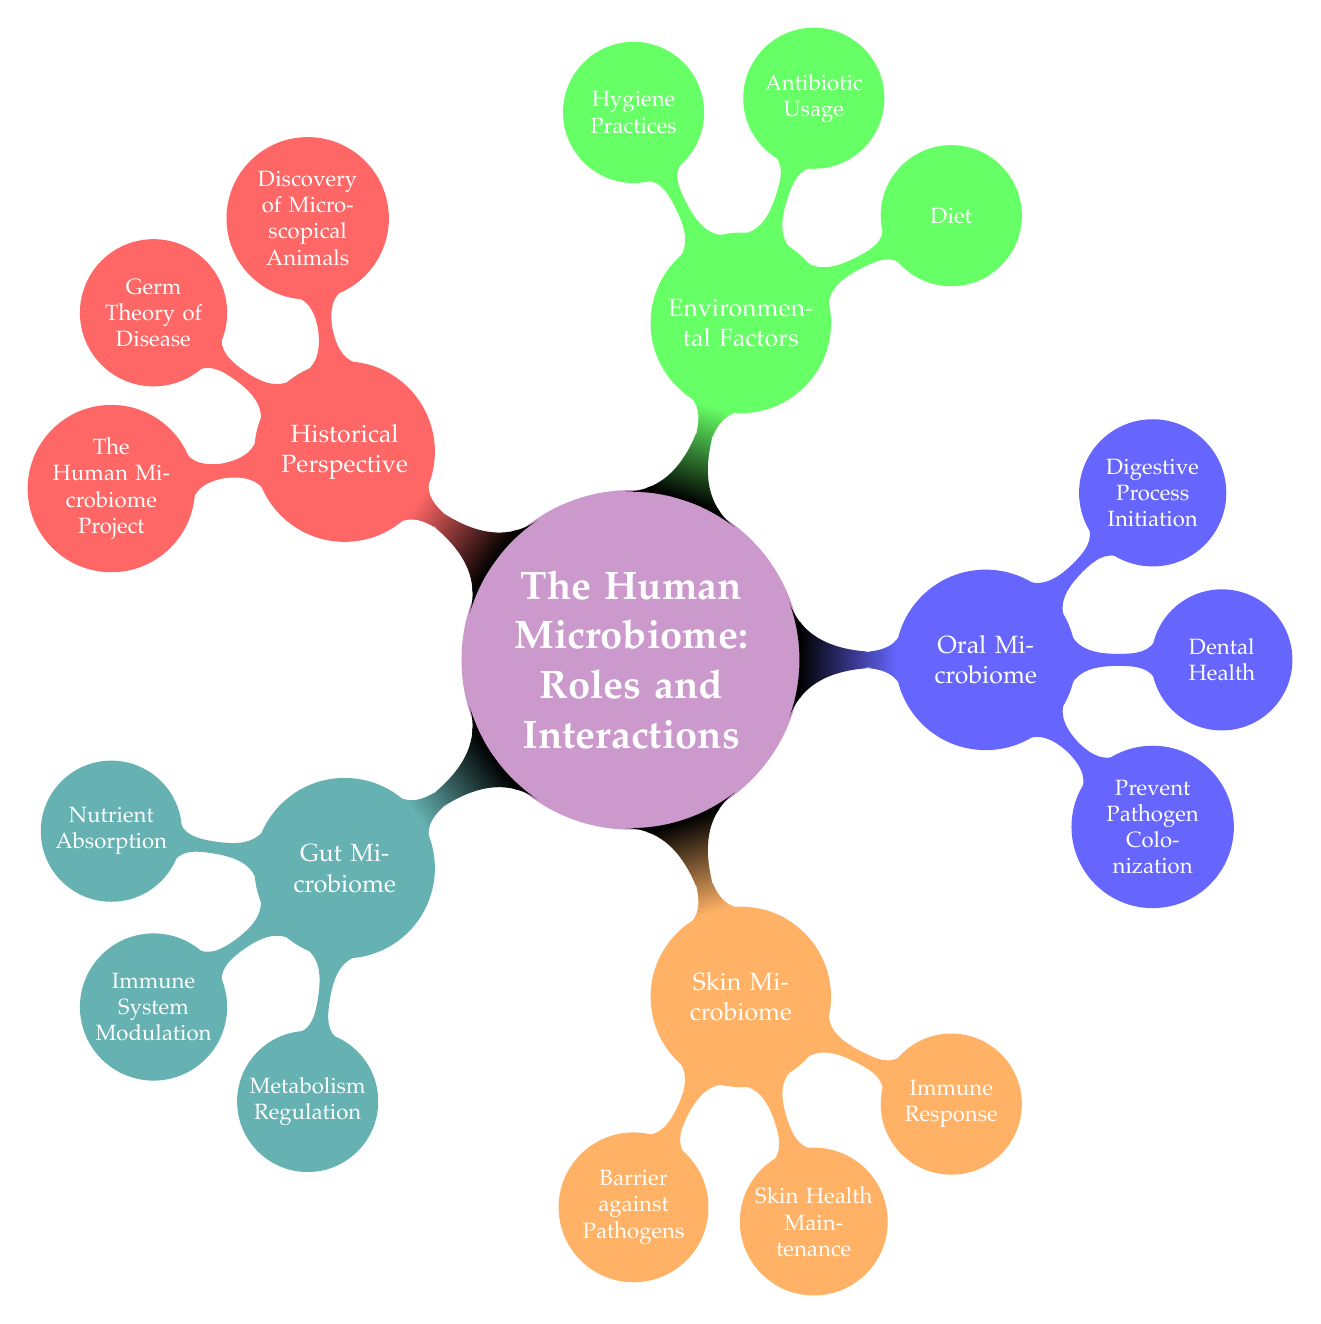What is the central concept of the diagram? The central concept is directly stated as "The Human Microbiome: Roles and Interactions" at the root level of the mind map.
Answer: The Human Microbiome: Roles and Interactions How many main types of microbiomes are presented in the diagram? The diagram presents five main types of microbiomes, which can be counted as Gut Microbiome, Skin Microbiome, Oral Microbiome, Environmental Factors, and Historical Perspective.
Answer: Five What is one of the key roles of the Gut Microbiome? The roles of the Gut Microbiome include nutrient absorption, immune system modulation, and metabolism regulation. Any of these roles can be considered as valid answers.
Answer: Nutrient Absorption Which microbiome is responsible for barrier against pathogens? The Skin Microbiome is specifically noted to have the role of providing a barrier against pathogens, as listed under its roles.
Answer: Skin Microbiome What external factors influence the human microbiome? The diagram specifies three external factors: diet, antibiotic usage, and hygiene practices that affect the human microbiome. The answer can list any of these factors.
Answer: Diet Which historical milestone is related to the discovery of microscopical animals? The milestone related to the discovery of microscopical animals is attributed to Antonie van Leeuwenhoek, indicated under the Historical Perspective node.
Answer: Discovery of Microscopical Animals How does diet impact the human microbiome according to the diagram? Diet influences the microbiome by affecting its diversity as stated under the Environmental Factors node, which discusses the impact of various external elements.
Answer: Microbiome Diversity Name a key organism found in the Oral Microbiome. The Oral Microbiome includes key organisms such as Streptococcus mutans, Lactobacillus, and Fusobacterium nucleatum, any one of these would be a correct answer.
Answer: Streptococcus mutans What does the Human Microbiome Project signify? The Human Microbiome Project, which began in 2008, is noted as a key milestone in the study of the human microbiome, representing an important development in microbiological research.
Answer: The Human Microbiome Project 